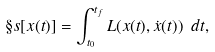Convert formula to latex. <formula><loc_0><loc_0><loc_500><loc_500>\S s [ x ( t ) ] = \int _ { t _ { 0 } } ^ { t _ { f } } L ( x ( t ) , { \dot { x } } ( t ) ) \ d t ,</formula> 